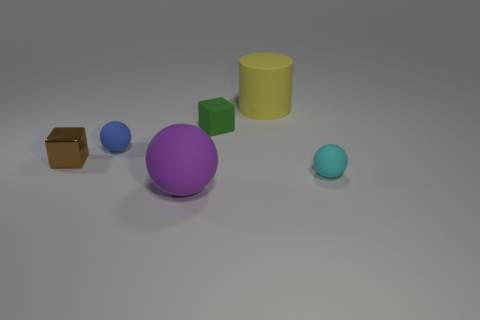Add 3 blue metal cylinders. How many objects exist? 9 Subtract all cylinders. How many objects are left? 5 Subtract all large spheres. Subtract all small rubber cubes. How many objects are left? 4 Add 2 big rubber things. How many big rubber things are left? 4 Add 3 blue cubes. How many blue cubes exist? 3 Subtract 1 brown blocks. How many objects are left? 5 